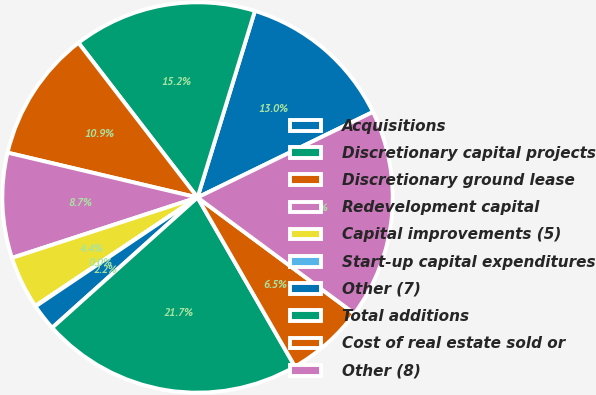Convert chart. <chart><loc_0><loc_0><loc_500><loc_500><pie_chart><fcel>Acquisitions<fcel>Discretionary capital projects<fcel>Discretionary ground lease<fcel>Redevelopment capital<fcel>Capital improvements (5)<fcel>Start-up capital expenditures<fcel>Other (7)<fcel>Total additions<fcel>Cost of real estate sold or<fcel>Other (8)<nl><fcel>13.03%<fcel>15.19%<fcel>10.87%<fcel>8.7%<fcel>4.37%<fcel>0.04%<fcel>2.21%<fcel>21.69%<fcel>6.54%<fcel>17.36%<nl></chart> 